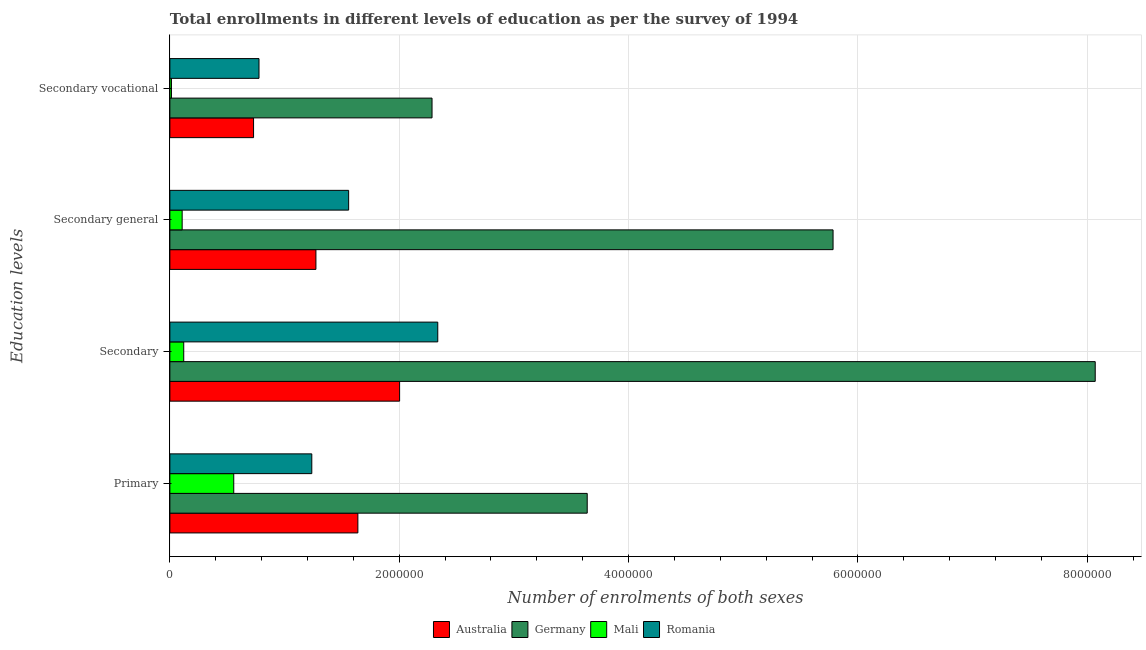How many different coloured bars are there?
Provide a succinct answer. 4. Are the number of bars per tick equal to the number of legend labels?
Make the answer very short. Yes. How many bars are there on the 1st tick from the top?
Your answer should be compact. 4. How many bars are there on the 4th tick from the bottom?
Provide a succinct answer. 4. What is the label of the 3rd group of bars from the top?
Provide a short and direct response. Secondary. What is the number of enrolments in secondary vocational education in Germany?
Offer a terse response. 2.29e+06. Across all countries, what is the maximum number of enrolments in secondary vocational education?
Provide a succinct answer. 2.29e+06. Across all countries, what is the minimum number of enrolments in primary education?
Offer a terse response. 5.57e+05. In which country was the number of enrolments in secondary education minimum?
Offer a terse response. Mali. What is the total number of enrolments in secondary vocational education in the graph?
Keep it short and to the point. 3.81e+06. What is the difference between the number of enrolments in secondary education in Australia and that in Romania?
Make the answer very short. -3.33e+05. What is the difference between the number of enrolments in secondary general education in Mali and the number of enrolments in primary education in Australia?
Offer a very short reply. -1.53e+06. What is the average number of enrolments in secondary general education per country?
Your answer should be very brief. 2.18e+06. What is the difference between the number of enrolments in secondary vocational education and number of enrolments in primary education in Germany?
Your response must be concise. -1.35e+06. What is the ratio of the number of enrolments in secondary education in Germany to that in Mali?
Offer a very short reply. 66.74. Is the number of enrolments in secondary general education in Romania less than that in Australia?
Make the answer very short. No. Is the difference between the number of enrolments in secondary vocational education in Germany and Australia greater than the difference between the number of enrolments in secondary general education in Germany and Australia?
Your answer should be very brief. No. What is the difference between the highest and the second highest number of enrolments in secondary education?
Your answer should be very brief. 5.73e+06. What is the difference between the highest and the lowest number of enrolments in secondary education?
Make the answer very short. 7.95e+06. In how many countries, is the number of enrolments in secondary general education greater than the average number of enrolments in secondary general education taken over all countries?
Your answer should be very brief. 1. What does the 1st bar from the top in Secondary represents?
Offer a very short reply. Romania. What does the 3rd bar from the bottom in Primary represents?
Offer a terse response. Mali. Is it the case that in every country, the sum of the number of enrolments in primary education and number of enrolments in secondary education is greater than the number of enrolments in secondary general education?
Keep it short and to the point. Yes. How many countries are there in the graph?
Your answer should be very brief. 4. Does the graph contain grids?
Make the answer very short. Yes. Where does the legend appear in the graph?
Your answer should be compact. Bottom center. How many legend labels are there?
Your response must be concise. 4. How are the legend labels stacked?
Offer a terse response. Horizontal. What is the title of the graph?
Your answer should be very brief. Total enrollments in different levels of education as per the survey of 1994. What is the label or title of the X-axis?
Provide a short and direct response. Number of enrolments of both sexes. What is the label or title of the Y-axis?
Offer a very short reply. Education levels. What is the Number of enrolments of both sexes in Australia in Primary?
Ensure brevity in your answer.  1.64e+06. What is the Number of enrolments of both sexes in Germany in Primary?
Give a very brief answer. 3.64e+06. What is the Number of enrolments of both sexes of Mali in Primary?
Keep it short and to the point. 5.57e+05. What is the Number of enrolments of both sexes of Romania in Primary?
Your response must be concise. 1.24e+06. What is the Number of enrolments of both sexes in Australia in Secondary?
Provide a short and direct response. 2.00e+06. What is the Number of enrolments of both sexes in Germany in Secondary?
Your response must be concise. 8.07e+06. What is the Number of enrolments of both sexes of Mali in Secondary?
Your answer should be compact. 1.21e+05. What is the Number of enrolments of both sexes in Romania in Secondary?
Your answer should be very brief. 2.34e+06. What is the Number of enrolments of both sexes in Australia in Secondary general?
Keep it short and to the point. 1.27e+06. What is the Number of enrolments of both sexes in Germany in Secondary general?
Ensure brevity in your answer.  5.78e+06. What is the Number of enrolments of both sexes of Mali in Secondary general?
Your answer should be very brief. 1.07e+05. What is the Number of enrolments of both sexes of Romania in Secondary general?
Ensure brevity in your answer.  1.56e+06. What is the Number of enrolments of both sexes of Australia in Secondary vocational?
Keep it short and to the point. 7.30e+05. What is the Number of enrolments of both sexes of Germany in Secondary vocational?
Give a very brief answer. 2.29e+06. What is the Number of enrolments of both sexes of Mali in Secondary vocational?
Your answer should be very brief. 1.38e+04. What is the Number of enrolments of both sexes of Romania in Secondary vocational?
Keep it short and to the point. 7.77e+05. Across all Education levels, what is the maximum Number of enrolments of both sexes in Australia?
Keep it short and to the point. 2.00e+06. Across all Education levels, what is the maximum Number of enrolments of both sexes of Germany?
Keep it short and to the point. 8.07e+06. Across all Education levels, what is the maximum Number of enrolments of both sexes in Mali?
Ensure brevity in your answer.  5.57e+05. Across all Education levels, what is the maximum Number of enrolments of both sexes in Romania?
Your response must be concise. 2.34e+06. Across all Education levels, what is the minimum Number of enrolments of both sexes in Australia?
Your answer should be compact. 7.30e+05. Across all Education levels, what is the minimum Number of enrolments of both sexes of Germany?
Keep it short and to the point. 2.29e+06. Across all Education levels, what is the minimum Number of enrolments of both sexes of Mali?
Your answer should be very brief. 1.38e+04. Across all Education levels, what is the minimum Number of enrolments of both sexes in Romania?
Ensure brevity in your answer.  7.77e+05. What is the total Number of enrolments of both sexes of Australia in the graph?
Your answer should be compact. 5.65e+06. What is the total Number of enrolments of both sexes of Germany in the graph?
Offer a terse response. 1.98e+07. What is the total Number of enrolments of both sexes of Mali in the graph?
Your answer should be compact. 7.99e+05. What is the total Number of enrolments of both sexes in Romania in the graph?
Keep it short and to the point. 5.91e+06. What is the difference between the Number of enrolments of both sexes of Australia in Primary and that in Secondary?
Your answer should be very brief. -3.64e+05. What is the difference between the Number of enrolments of both sexes in Germany in Primary and that in Secondary?
Give a very brief answer. -4.43e+06. What is the difference between the Number of enrolments of both sexes in Mali in Primary and that in Secondary?
Your answer should be very brief. 4.36e+05. What is the difference between the Number of enrolments of both sexes in Romania in Primary and that in Secondary?
Offer a very short reply. -1.10e+06. What is the difference between the Number of enrolments of both sexes of Australia in Primary and that in Secondary general?
Your response must be concise. 3.66e+05. What is the difference between the Number of enrolments of both sexes of Germany in Primary and that in Secondary general?
Keep it short and to the point. -2.14e+06. What is the difference between the Number of enrolments of both sexes of Mali in Primary and that in Secondary general?
Ensure brevity in your answer.  4.50e+05. What is the difference between the Number of enrolments of both sexes of Romania in Primary and that in Secondary general?
Your answer should be very brief. -3.21e+05. What is the difference between the Number of enrolments of both sexes of Australia in Primary and that in Secondary vocational?
Your response must be concise. 9.10e+05. What is the difference between the Number of enrolments of both sexes in Germany in Primary and that in Secondary vocational?
Keep it short and to the point. 1.35e+06. What is the difference between the Number of enrolments of both sexes of Mali in Primary and that in Secondary vocational?
Offer a very short reply. 5.43e+05. What is the difference between the Number of enrolments of both sexes of Romania in Primary and that in Secondary vocational?
Keep it short and to the point. 4.60e+05. What is the difference between the Number of enrolments of both sexes in Australia in Secondary and that in Secondary general?
Your answer should be very brief. 7.30e+05. What is the difference between the Number of enrolments of both sexes in Germany in Secondary and that in Secondary general?
Keep it short and to the point. 2.29e+06. What is the difference between the Number of enrolments of both sexes in Mali in Secondary and that in Secondary general?
Offer a terse response. 1.38e+04. What is the difference between the Number of enrolments of both sexes in Romania in Secondary and that in Secondary general?
Ensure brevity in your answer.  7.77e+05. What is the difference between the Number of enrolments of both sexes of Australia in Secondary and that in Secondary vocational?
Ensure brevity in your answer.  1.27e+06. What is the difference between the Number of enrolments of both sexes of Germany in Secondary and that in Secondary vocational?
Keep it short and to the point. 5.78e+06. What is the difference between the Number of enrolments of both sexes of Mali in Secondary and that in Secondary vocational?
Your answer should be very brief. 1.07e+05. What is the difference between the Number of enrolments of both sexes of Romania in Secondary and that in Secondary vocational?
Offer a terse response. 1.56e+06. What is the difference between the Number of enrolments of both sexes of Australia in Secondary general and that in Secondary vocational?
Your answer should be compact. 5.44e+05. What is the difference between the Number of enrolments of both sexes in Germany in Secondary general and that in Secondary vocational?
Give a very brief answer. 3.50e+06. What is the difference between the Number of enrolments of both sexes of Mali in Secondary general and that in Secondary vocational?
Ensure brevity in your answer.  9.33e+04. What is the difference between the Number of enrolments of both sexes of Romania in Secondary general and that in Secondary vocational?
Give a very brief answer. 7.82e+05. What is the difference between the Number of enrolments of both sexes in Australia in Primary and the Number of enrolments of both sexes in Germany in Secondary?
Offer a very short reply. -6.43e+06. What is the difference between the Number of enrolments of both sexes in Australia in Primary and the Number of enrolments of both sexes in Mali in Secondary?
Give a very brief answer. 1.52e+06. What is the difference between the Number of enrolments of both sexes of Australia in Primary and the Number of enrolments of both sexes of Romania in Secondary?
Provide a short and direct response. -6.97e+05. What is the difference between the Number of enrolments of both sexes of Germany in Primary and the Number of enrolments of both sexes of Mali in Secondary?
Provide a succinct answer. 3.52e+06. What is the difference between the Number of enrolments of both sexes of Germany in Primary and the Number of enrolments of both sexes of Romania in Secondary?
Offer a very short reply. 1.30e+06. What is the difference between the Number of enrolments of both sexes of Mali in Primary and the Number of enrolments of both sexes of Romania in Secondary?
Offer a very short reply. -1.78e+06. What is the difference between the Number of enrolments of both sexes of Australia in Primary and the Number of enrolments of both sexes of Germany in Secondary general?
Offer a terse response. -4.14e+06. What is the difference between the Number of enrolments of both sexes of Australia in Primary and the Number of enrolments of both sexes of Mali in Secondary general?
Your response must be concise. 1.53e+06. What is the difference between the Number of enrolments of both sexes in Australia in Primary and the Number of enrolments of both sexes in Romania in Secondary general?
Provide a short and direct response. 8.05e+04. What is the difference between the Number of enrolments of both sexes of Germany in Primary and the Number of enrolments of both sexes of Mali in Secondary general?
Your response must be concise. 3.53e+06. What is the difference between the Number of enrolments of both sexes of Germany in Primary and the Number of enrolments of both sexes of Romania in Secondary general?
Provide a short and direct response. 2.08e+06. What is the difference between the Number of enrolments of both sexes of Mali in Primary and the Number of enrolments of both sexes of Romania in Secondary general?
Give a very brief answer. -1.00e+06. What is the difference between the Number of enrolments of both sexes in Australia in Primary and the Number of enrolments of both sexes in Germany in Secondary vocational?
Your answer should be very brief. -6.47e+05. What is the difference between the Number of enrolments of both sexes in Australia in Primary and the Number of enrolments of both sexes in Mali in Secondary vocational?
Provide a short and direct response. 1.63e+06. What is the difference between the Number of enrolments of both sexes in Australia in Primary and the Number of enrolments of both sexes in Romania in Secondary vocational?
Provide a short and direct response. 8.62e+05. What is the difference between the Number of enrolments of both sexes of Germany in Primary and the Number of enrolments of both sexes of Mali in Secondary vocational?
Offer a very short reply. 3.63e+06. What is the difference between the Number of enrolments of both sexes of Germany in Primary and the Number of enrolments of both sexes of Romania in Secondary vocational?
Provide a succinct answer. 2.86e+06. What is the difference between the Number of enrolments of both sexes in Mali in Primary and the Number of enrolments of both sexes in Romania in Secondary vocational?
Your response must be concise. -2.20e+05. What is the difference between the Number of enrolments of both sexes of Australia in Secondary and the Number of enrolments of both sexes of Germany in Secondary general?
Offer a terse response. -3.78e+06. What is the difference between the Number of enrolments of both sexes of Australia in Secondary and the Number of enrolments of both sexes of Mali in Secondary general?
Ensure brevity in your answer.  1.90e+06. What is the difference between the Number of enrolments of both sexes in Australia in Secondary and the Number of enrolments of both sexes in Romania in Secondary general?
Offer a very short reply. 4.44e+05. What is the difference between the Number of enrolments of both sexes in Germany in Secondary and the Number of enrolments of both sexes in Mali in Secondary general?
Give a very brief answer. 7.96e+06. What is the difference between the Number of enrolments of both sexes in Germany in Secondary and the Number of enrolments of both sexes in Romania in Secondary general?
Your answer should be compact. 6.51e+06. What is the difference between the Number of enrolments of both sexes of Mali in Secondary and the Number of enrolments of both sexes of Romania in Secondary general?
Your answer should be compact. -1.44e+06. What is the difference between the Number of enrolments of both sexes in Australia in Secondary and the Number of enrolments of both sexes in Germany in Secondary vocational?
Keep it short and to the point. -2.83e+05. What is the difference between the Number of enrolments of both sexes in Australia in Secondary and the Number of enrolments of both sexes in Mali in Secondary vocational?
Keep it short and to the point. 1.99e+06. What is the difference between the Number of enrolments of both sexes of Australia in Secondary and the Number of enrolments of both sexes of Romania in Secondary vocational?
Ensure brevity in your answer.  1.23e+06. What is the difference between the Number of enrolments of both sexes of Germany in Secondary and the Number of enrolments of both sexes of Mali in Secondary vocational?
Offer a terse response. 8.06e+06. What is the difference between the Number of enrolments of both sexes of Germany in Secondary and the Number of enrolments of both sexes of Romania in Secondary vocational?
Your answer should be compact. 7.29e+06. What is the difference between the Number of enrolments of both sexes in Mali in Secondary and the Number of enrolments of both sexes in Romania in Secondary vocational?
Offer a terse response. -6.56e+05. What is the difference between the Number of enrolments of both sexes in Australia in Secondary general and the Number of enrolments of both sexes in Germany in Secondary vocational?
Ensure brevity in your answer.  -1.01e+06. What is the difference between the Number of enrolments of both sexes of Australia in Secondary general and the Number of enrolments of both sexes of Mali in Secondary vocational?
Provide a short and direct response. 1.26e+06. What is the difference between the Number of enrolments of both sexes in Australia in Secondary general and the Number of enrolments of both sexes in Romania in Secondary vocational?
Keep it short and to the point. 4.96e+05. What is the difference between the Number of enrolments of both sexes in Germany in Secondary general and the Number of enrolments of both sexes in Mali in Secondary vocational?
Provide a short and direct response. 5.77e+06. What is the difference between the Number of enrolments of both sexes of Germany in Secondary general and the Number of enrolments of both sexes of Romania in Secondary vocational?
Make the answer very short. 5.01e+06. What is the difference between the Number of enrolments of both sexes in Mali in Secondary general and the Number of enrolments of both sexes in Romania in Secondary vocational?
Keep it short and to the point. -6.70e+05. What is the average Number of enrolments of both sexes in Australia per Education levels?
Ensure brevity in your answer.  1.41e+06. What is the average Number of enrolments of both sexes in Germany per Education levels?
Provide a succinct answer. 4.94e+06. What is the average Number of enrolments of both sexes in Mali per Education levels?
Provide a short and direct response. 2.00e+05. What is the average Number of enrolments of both sexes of Romania per Education levels?
Keep it short and to the point. 1.48e+06. What is the difference between the Number of enrolments of both sexes of Australia and Number of enrolments of both sexes of Germany in Primary?
Offer a very short reply. -2.00e+06. What is the difference between the Number of enrolments of both sexes in Australia and Number of enrolments of both sexes in Mali in Primary?
Your answer should be very brief. 1.08e+06. What is the difference between the Number of enrolments of both sexes of Australia and Number of enrolments of both sexes of Romania in Primary?
Provide a succinct answer. 4.02e+05. What is the difference between the Number of enrolments of both sexes of Germany and Number of enrolments of both sexes of Mali in Primary?
Give a very brief answer. 3.08e+06. What is the difference between the Number of enrolments of both sexes in Germany and Number of enrolments of both sexes in Romania in Primary?
Your answer should be very brief. 2.40e+06. What is the difference between the Number of enrolments of both sexes in Mali and Number of enrolments of both sexes in Romania in Primary?
Offer a terse response. -6.81e+05. What is the difference between the Number of enrolments of both sexes of Australia and Number of enrolments of both sexes of Germany in Secondary?
Provide a short and direct response. -6.07e+06. What is the difference between the Number of enrolments of both sexes in Australia and Number of enrolments of both sexes in Mali in Secondary?
Make the answer very short. 1.88e+06. What is the difference between the Number of enrolments of both sexes of Australia and Number of enrolments of both sexes of Romania in Secondary?
Make the answer very short. -3.33e+05. What is the difference between the Number of enrolments of both sexes in Germany and Number of enrolments of both sexes in Mali in Secondary?
Provide a succinct answer. 7.95e+06. What is the difference between the Number of enrolments of both sexes of Germany and Number of enrolments of both sexes of Romania in Secondary?
Your answer should be very brief. 5.73e+06. What is the difference between the Number of enrolments of both sexes of Mali and Number of enrolments of both sexes of Romania in Secondary?
Offer a terse response. -2.22e+06. What is the difference between the Number of enrolments of both sexes in Australia and Number of enrolments of both sexes in Germany in Secondary general?
Ensure brevity in your answer.  -4.51e+06. What is the difference between the Number of enrolments of both sexes in Australia and Number of enrolments of both sexes in Mali in Secondary general?
Your answer should be very brief. 1.17e+06. What is the difference between the Number of enrolments of both sexes of Australia and Number of enrolments of both sexes of Romania in Secondary general?
Your answer should be compact. -2.85e+05. What is the difference between the Number of enrolments of both sexes in Germany and Number of enrolments of both sexes in Mali in Secondary general?
Keep it short and to the point. 5.68e+06. What is the difference between the Number of enrolments of both sexes in Germany and Number of enrolments of both sexes in Romania in Secondary general?
Make the answer very short. 4.22e+06. What is the difference between the Number of enrolments of both sexes in Mali and Number of enrolments of both sexes in Romania in Secondary general?
Provide a short and direct response. -1.45e+06. What is the difference between the Number of enrolments of both sexes in Australia and Number of enrolments of both sexes in Germany in Secondary vocational?
Offer a terse response. -1.56e+06. What is the difference between the Number of enrolments of both sexes of Australia and Number of enrolments of both sexes of Mali in Secondary vocational?
Give a very brief answer. 7.16e+05. What is the difference between the Number of enrolments of both sexes of Australia and Number of enrolments of both sexes of Romania in Secondary vocational?
Give a very brief answer. -4.74e+04. What is the difference between the Number of enrolments of both sexes of Germany and Number of enrolments of both sexes of Mali in Secondary vocational?
Offer a very short reply. 2.27e+06. What is the difference between the Number of enrolments of both sexes in Germany and Number of enrolments of both sexes in Romania in Secondary vocational?
Give a very brief answer. 1.51e+06. What is the difference between the Number of enrolments of both sexes in Mali and Number of enrolments of both sexes in Romania in Secondary vocational?
Your response must be concise. -7.63e+05. What is the ratio of the Number of enrolments of both sexes of Australia in Primary to that in Secondary?
Make the answer very short. 0.82. What is the ratio of the Number of enrolments of both sexes of Germany in Primary to that in Secondary?
Ensure brevity in your answer.  0.45. What is the ratio of the Number of enrolments of both sexes in Mali in Primary to that in Secondary?
Keep it short and to the point. 4.61. What is the ratio of the Number of enrolments of both sexes in Romania in Primary to that in Secondary?
Your answer should be compact. 0.53. What is the ratio of the Number of enrolments of both sexes in Australia in Primary to that in Secondary general?
Offer a very short reply. 1.29. What is the ratio of the Number of enrolments of both sexes in Germany in Primary to that in Secondary general?
Provide a succinct answer. 0.63. What is the ratio of the Number of enrolments of both sexes in Mali in Primary to that in Secondary general?
Your response must be concise. 5.2. What is the ratio of the Number of enrolments of both sexes in Romania in Primary to that in Secondary general?
Provide a succinct answer. 0.79. What is the ratio of the Number of enrolments of both sexes of Australia in Primary to that in Secondary vocational?
Give a very brief answer. 2.25. What is the ratio of the Number of enrolments of both sexes in Germany in Primary to that in Secondary vocational?
Offer a very short reply. 1.59. What is the ratio of the Number of enrolments of both sexes of Mali in Primary to that in Secondary vocational?
Your answer should be very brief. 40.35. What is the ratio of the Number of enrolments of both sexes in Romania in Primary to that in Secondary vocational?
Provide a short and direct response. 1.59. What is the ratio of the Number of enrolments of both sexes in Australia in Secondary to that in Secondary general?
Your response must be concise. 1.57. What is the ratio of the Number of enrolments of both sexes in Germany in Secondary to that in Secondary general?
Keep it short and to the point. 1.4. What is the ratio of the Number of enrolments of both sexes of Mali in Secondary to that in Secondary general?
Make the answer very short. 1.13. What is the ratio of the Number of enrolments of both sexes in Romania in Secondary to that in Secondary general?
Make the answer very short. 1.5. What is the ratio of the Number of enrolments of both sexes in Australia in Secondary to that in Secondary vocational?
Ensure brevity in your answer.  2.75. What is the ratio of the Number of enrolments of both sexes in Germany in Secondary to that in Secondary vocational?
Offer a very short reply. 3.53. What is the ratio of the Number of enrolments of both sexes of Mali in Secondary to that in Secondary vocational?
Your answer should be compact. 8.76. What is the ratio of the Number of enrolments of both sexes in Romania in Secondary to that in Secondary vocational?
Your answer should be compact. 3.01. What is the ratio of the Number of enrolments of both sexes of Australia in Secondary general to that in Secondary vocational?
Make the answer very short. 1.75. What is the ratio of the Number of enrolments of both sexes in Germany in Secondary general to that in Secondary vocational?
Provide a short and direct response. 2.53. What is the ratio of the Number of enrolments of both sexes of Mali in Secondary general to that in Secondary vocational?
Offer a terse response. 7.76. What is the ratio of the Number of enrolments of both sexes of Romania in Secondary general to that in Secondary vocational?
Your answer should be compact. 2.01. What is the difference between the highest and the second highest Number of enrolments of both sexes of Australia?
Give a very brief answer. 3.64e+05. What is the difference between the highest and the second highest Number of enrolments of both sexes of Germany?
Your answer should be very brief. 2.29e+06. What is the difference between the highest and the second highest Number of enrolments of both sexes in Mali?
Provide a short and direct response. 4.36e+05. What is the difference between the highest and the second highest Number of enrolments of both sexes of Romania?
Your answer should be compact. 7.77e+05. What is the difference between the highest and the lowest Number of enrolments of both sexes of Australia?
Provide a short and direct response. 1.27e+06. What is the difference between the highest and the lowest Number of enrolments of both sexes in Germany?
Your answer should be very brief. 5.78e+06. What is the difference between the highest and the lowest Number of enrolments of both sexes in Mali?
Offer a terse response. 5.43e+05. What is the difference between the highest and the lowest Number of enrolments of both sexes in Romania?
Ensure brevity in your answer.  1.56e+06. 